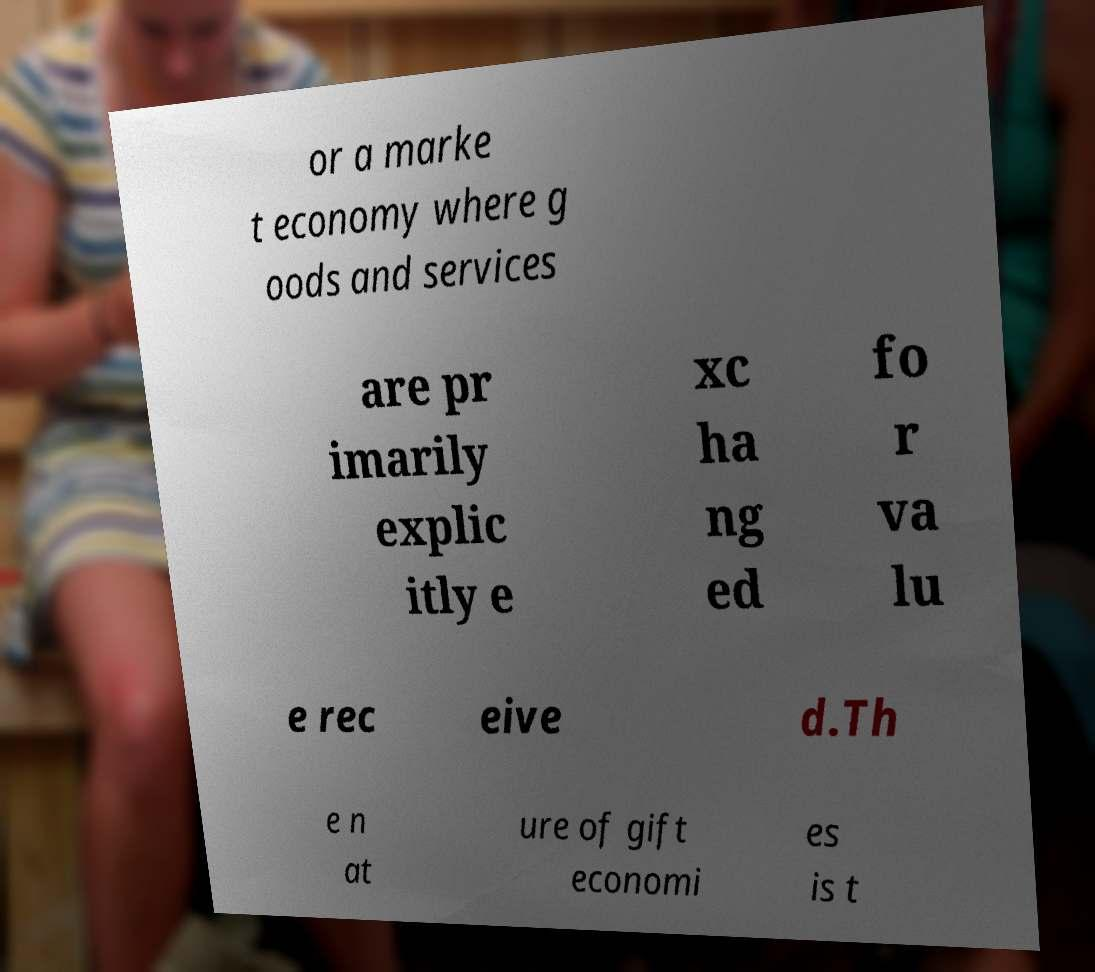Can you read and provide the text displayed in the image?This photo seems to have some interesting text. Can you extract and type it out for me? or a marke t economy where g oods and services are pr imarily explic itly e xc ha ng ed fo r va lu e rec eive d.Th e n at ure of gift economi es is t 